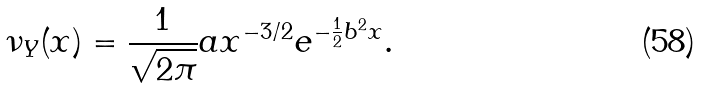<formula> <loc_0><loc_0><loc_500><loc_500>\nu _ { Y } ( x ) = \frac { 1 } { \sqrt { 2 \pi } } a x ^ { - 3 / 2 } e ^ { - \frac { 1 } { 2 } b ^ { 2 } x } .</formula> 